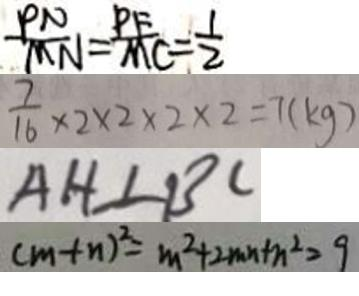Convert formula to latex. <formula><loc_0><loc_0><loc_500><loc_500>\frac { P N } { M N } = \frac { P F } { M C } = \frac { 1 } { 2 } 
 \frac { 7 } { 1 6 } \times 2 \times 2 \times 2 \times 2 = 7 ( k g ) 
 A H \bot B C 
 ( m + n ) ^ { 2 } = m ^ { 2 } + 2 m n + n ^ { 2 } = 9</formula> 